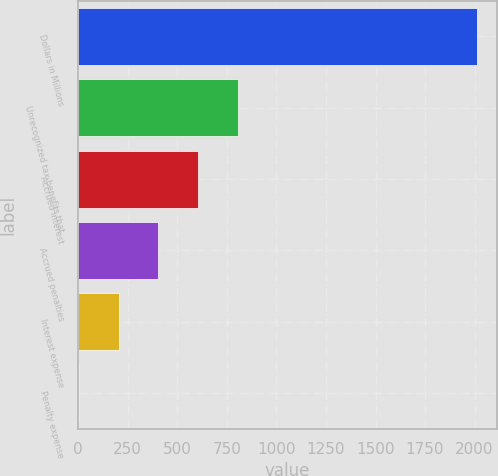<chart> <loc_0><loc_0><loc_500><loc_500><bar_chart><fcel>Dollars in Millions<fcel>Unrecognized tax benefits that<fcel>Accrued interest<fcel>Accrued penalties<fcel>Interest expense<fcel>Penalty expense<nl><fcel>2013<fcel>807<fcel>606<fcel>405<fcel>204<fcel>3<nl></chart> 